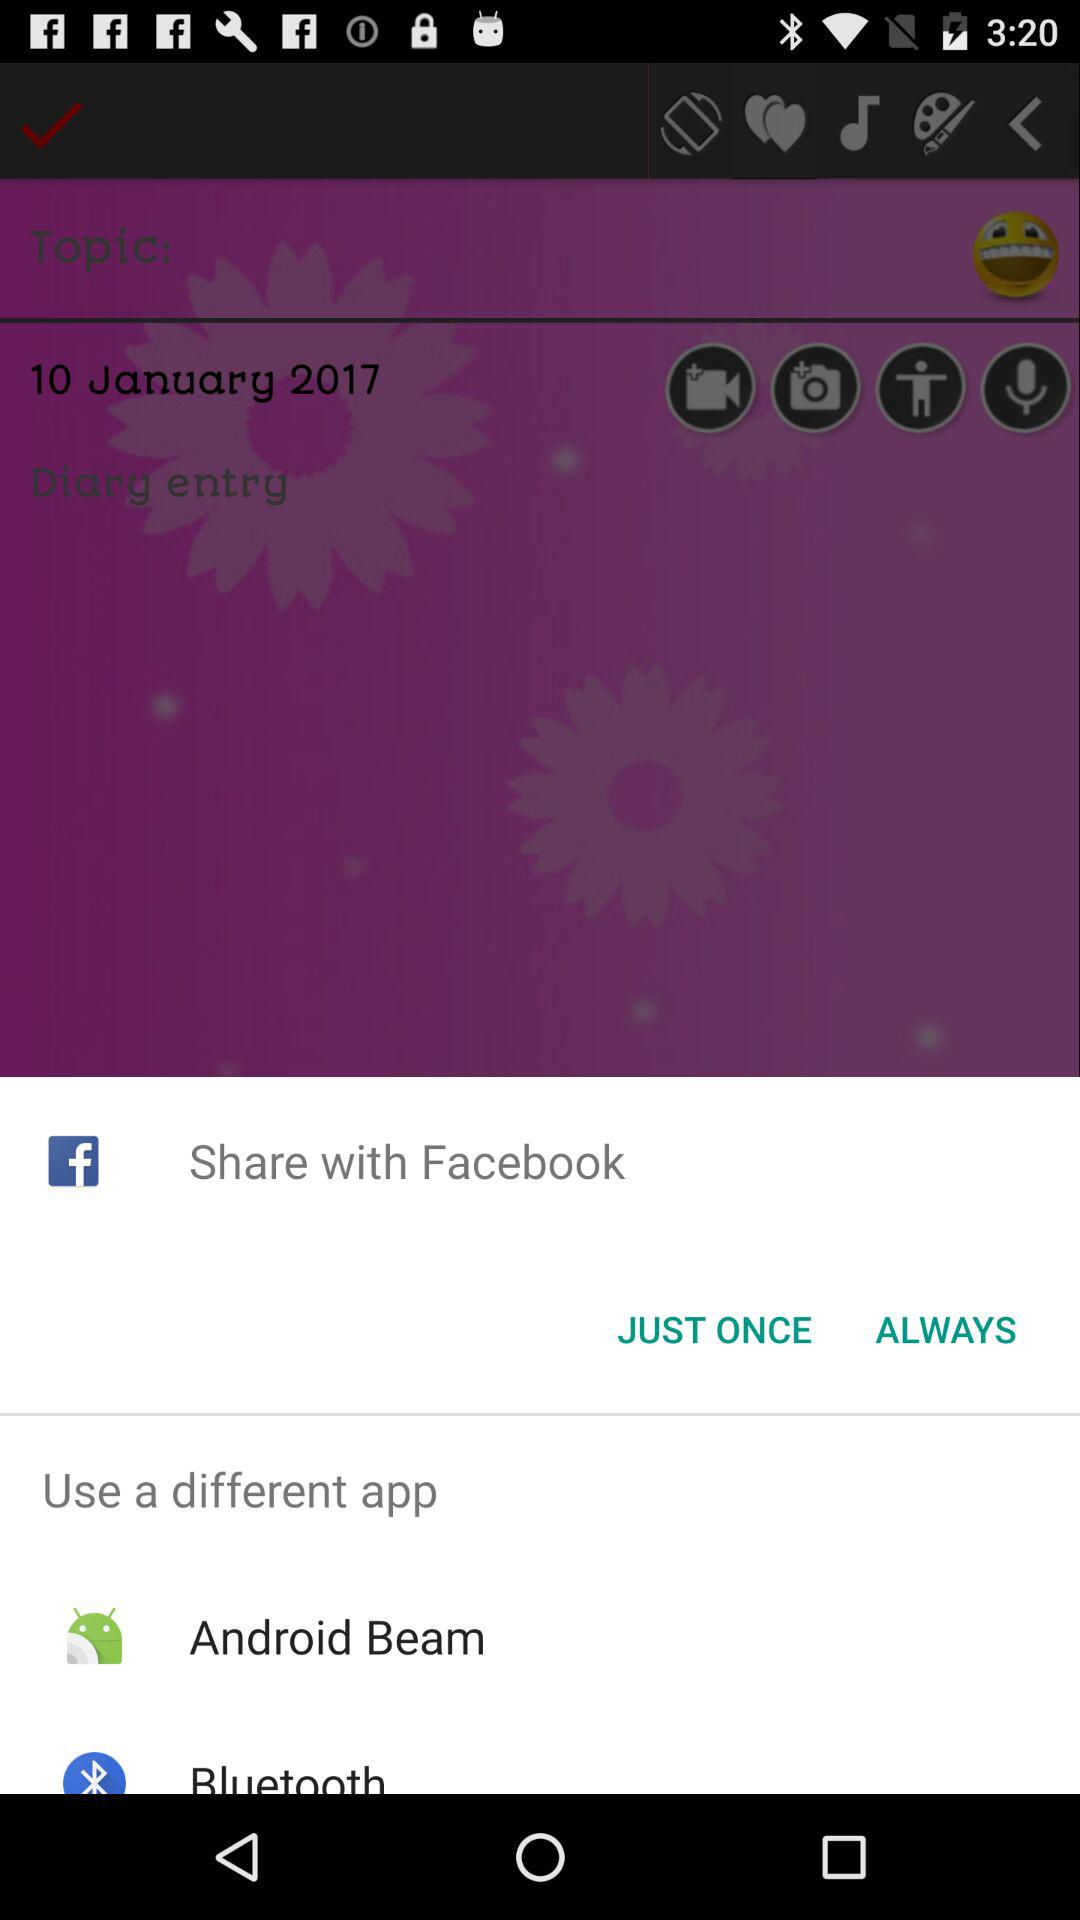What is the topic date? The topic date is 10 January 2017. 